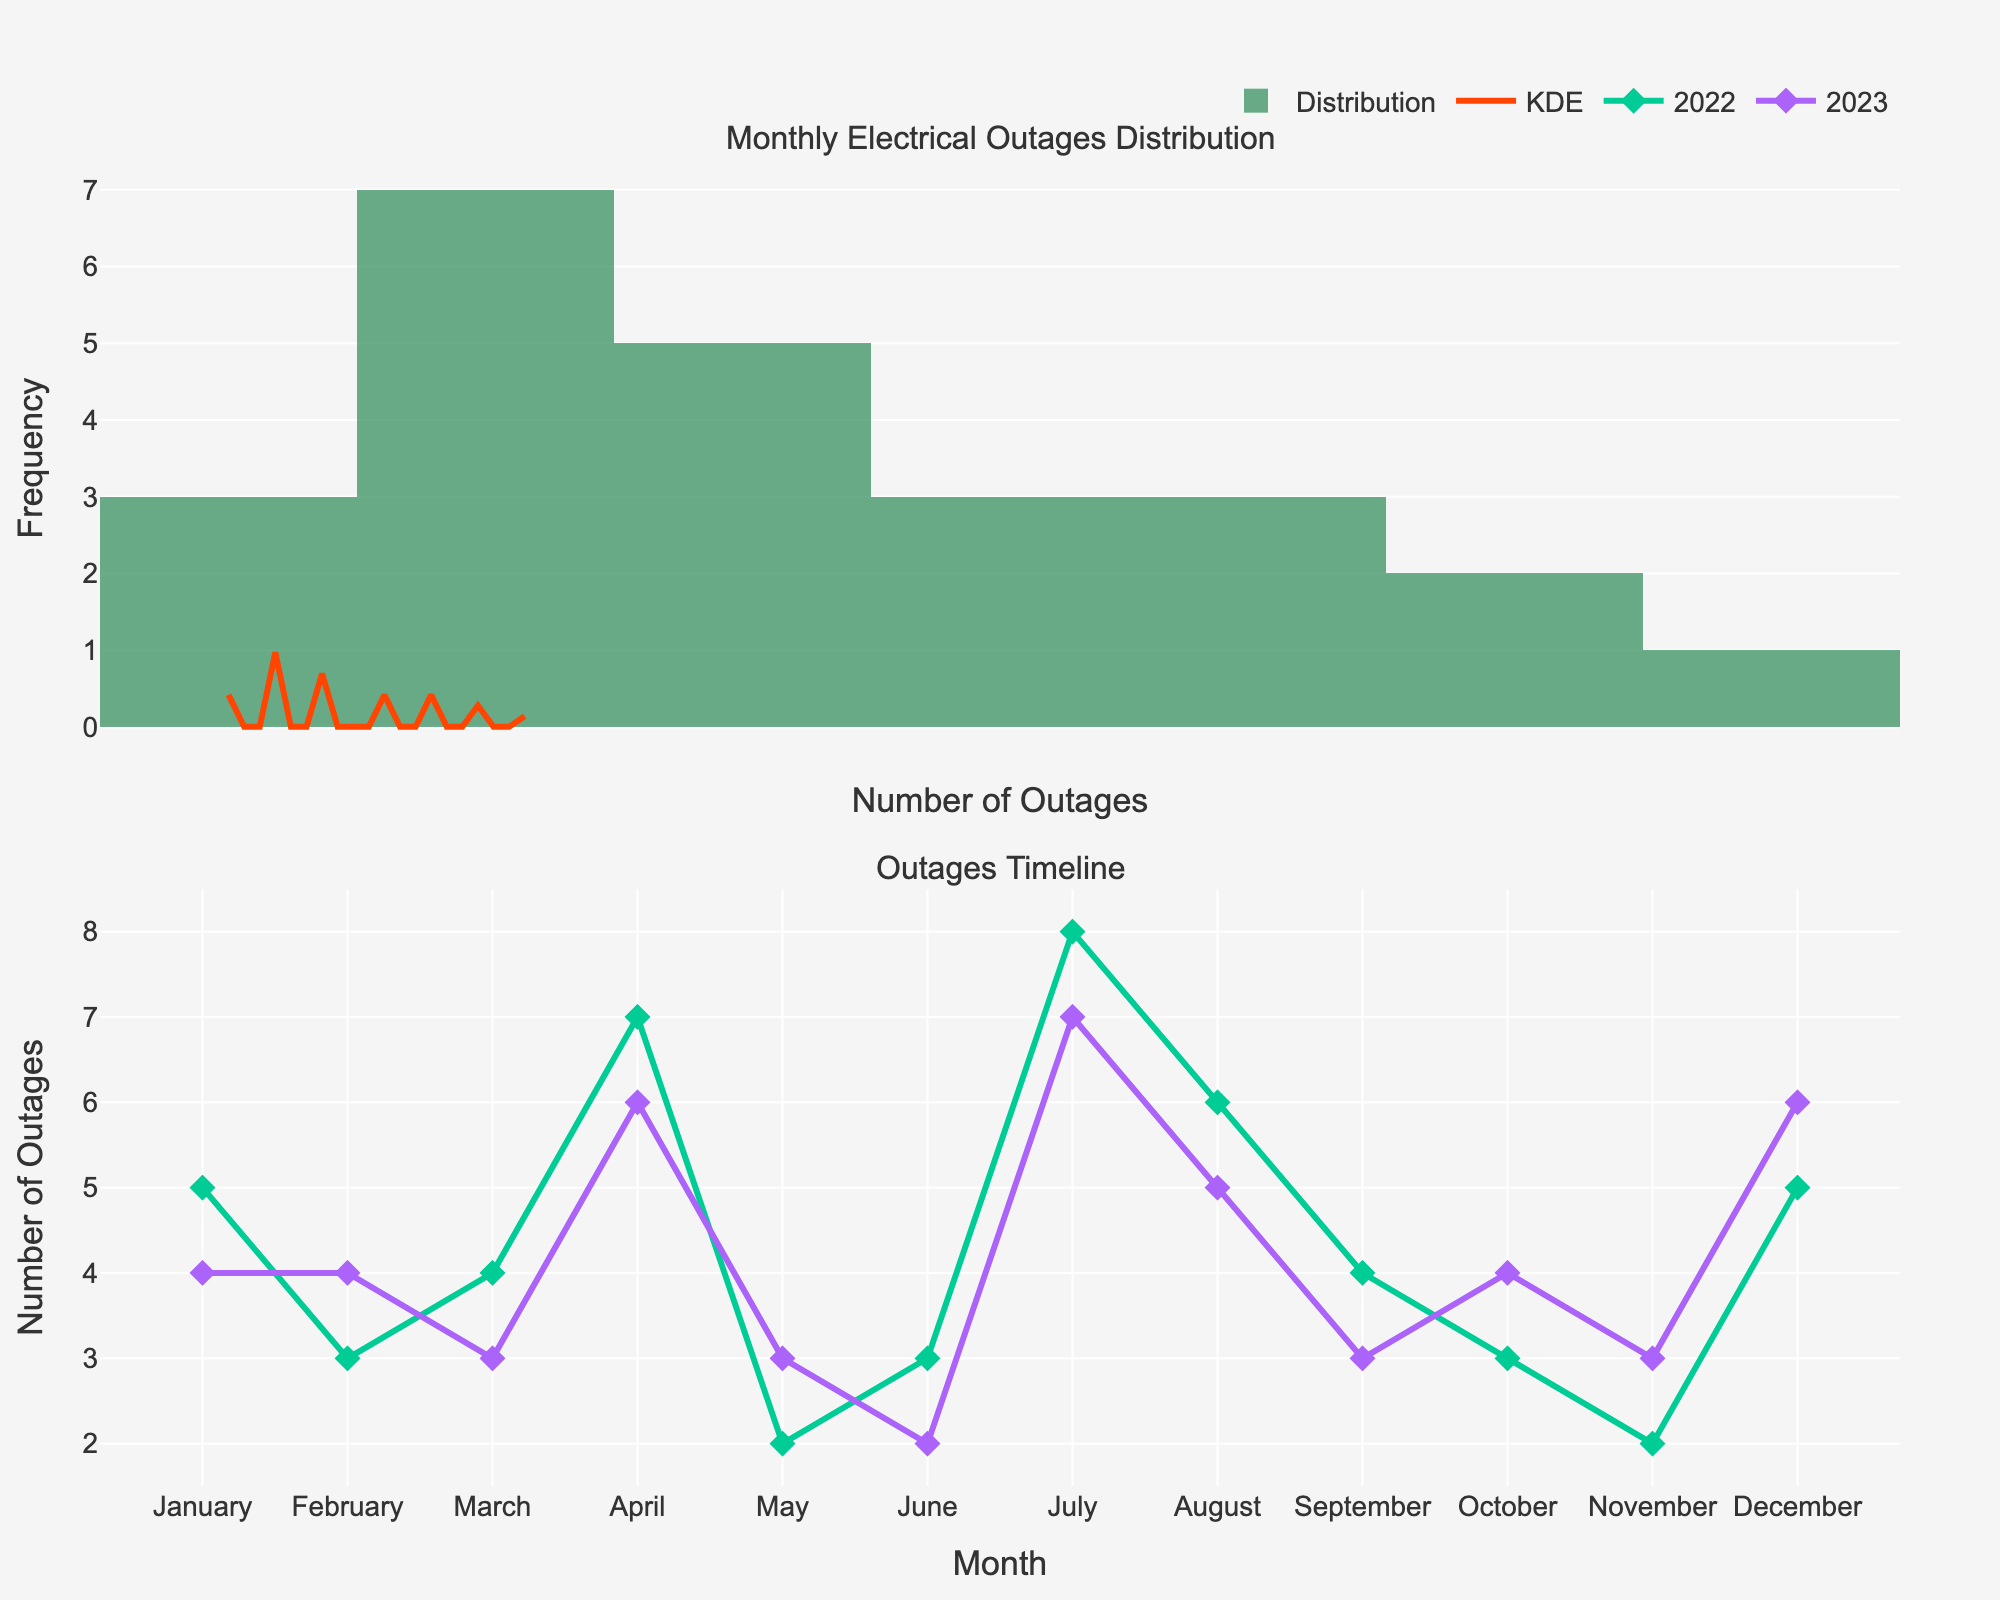What is the title of the first plot? The title of the first plot is clearly labeled at the top of the first subplot.
Answer: Monthly Electrical Outages Distribution What does the orange line in the first plot represent? The orange line in the first plot represents the KDE (Kernel Density Estimation), which is used to estimate the probability density function of the number of outages.
Answer: KDE In which month and year did the village have the highest number of electrical outages? By looking at the second subplot (timeline plot), the highest value is in July 2022.
Answer: July 2022 How many outages occurred in July 2023? By referring to the second subplot where July 2023 data points are plotted, we can see the mark corresponding to July 2023 at 7 outages.
Answer: 7 Which year had a more even distribution of electrical outages over the months, 2022 or 2023? Examining the second subplot (timeline plot), we observe that the values in 2022 show more variation month-to-month, while 2023 values are more consistent.
Answer: 2023 What is the most frequent number of outages per month? Observing the histogram in the first plot, the bar with the highest frequency corresponds to the number of outages, which is 3.
Answer: 3 Are there any months with zero outages across the two years? The timeline plot indicates that every month has at least some outages as all months have points plotted.
Answer: No How does the number of outages in April 2022 compare to April 2023? Looking at the timeline plot, the number of outages in April 2022 is higher (7) compared to April 2023 (6).
Answer: April 2022 is higher Which months experienced an increase in outages from 2022 to 2023? Comparing the month-by-month data in the timeline plot, April and December show an increase in the number of outages from 2022 to 2023.
Answer: April and December 